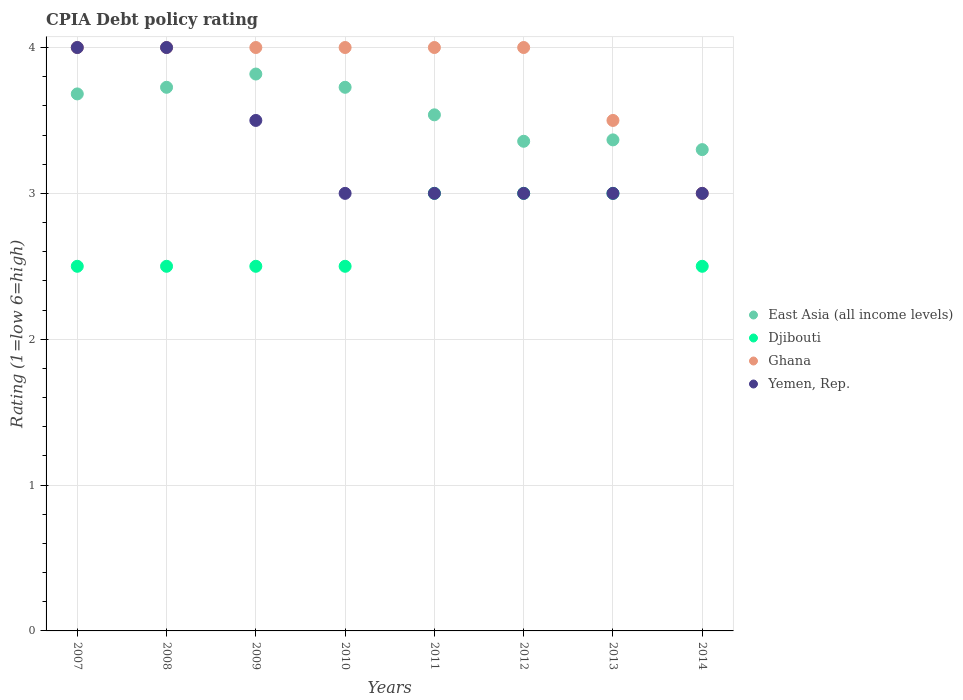How many different coloured dotlines are there?
Your response must be concise. 4. Across all years, what is the maximum CPIA rating in East Asia (all income levels)?
Offer a very short reply. 3.82. What is the total CPIA rating in Djibouti in the graph?
Provide a succinct answer. 21.5. What is the difference between the CPIA rating in Yemen, Rep. in 2013 and the CPIA rating in Djibouti in 2012?
Keep it short and to the point. 0. What is the average CPIA rating in Ghana per year?
Ensure brevity in your answer.  3.81. In the year 2010, what is the difference between the CPIA rating in East Asia (all income levels) and CPIA rating in Ghana?
Offer a very short reply. -0.27. In how many years, is the CPIA rating in East Asia (all income levels) greater than 3.4?
Offer a terse response. 5. What is the difference between the highest and the second highest CPIA rating in Yemen, Rep.?
Your answer should be compact. 0. Is the CPIA rating in Yemen, Rep. strictly greater than the CPIA rating in Djibouti over the years?
Offer a terse response. No. What is the difference between two consecutive major ticks on the Y-axis?
Offer a very short reply. 1. Does the graph contain any zero values?
Ensure brevity in your answer.  No. Where does the legend appear in the graph?
Your response must be concise. Center right. What is the title of the graph?
Provide a short and direct response. CPIA Debt policy rating. What is the label or title of the X-axis?
Your response must be concise. Years. What is the label or title of the Y-axis?
Your answer should be very brief. Rating (1=low 6=high). What is the Rating (1=low 6=high) of East Asia (all income levels) in 2007?
Your answer should be compact. 3.68. What is the Rating (1=low 6=high) of Yemen, Rep. in 2007?
Offer a very short reply. 4. What is the Rating (1=low 6=high) in East Asia (all income levels) in 2008?
Make the answer very short. 3.73. What is the Rating (1=low 6=high) of Ghana in 2008?
Make the answer very short. 4. What is the Rating (1=low 6=high) in East Asia (all income levels) in 2009?
Your answer should be compact. 3.82. What is the Rating (1=low 6=high) in East Asia (all income levels) in 2010?
Your response must be concise. 3.73. What is the Rating (1=low 6=high) in Djibouti in 2010?
Give a very brief answer. 2.5. What is the Rating (1=low 6=high) of East Asia (all income levels) in 2011?
Ensure brevity in your answer.  3.54. What is the Rating (1=low 6=high) in Djibouti in 2011?
Give a very brief answer. 3. What is the Rating (1=low 6=high) in Ghana in 2011?
Give a very brief answer. 4. What is the Rating (1=low 6=high) of Yemen, Rep. in 2011?
Provide a short and direct response. 3. What is the Rating (1=low 6=high) of East Asia (all income levels) in 2012?
Your answer should be compact. 3.36. What is the Rating (1=low 6=high) of Djibouti in 2012?
Your response must be concise. 3. What is the Rating (1=low 6=high) in Yemen, Rep. in 2012?
Your response must be concise. 3. What is the Rating (1=low 6=high) of East Asia (all income levels) in 2013?
Provide a short and direct response. 3.37. What is the Rating (1=low 6=high) in Yemen, Rep. in 2013?
Keep it short and to the point. 3. What is the Rating (1=low 6=high) of East Asia (all income levels) in 2014?
Give a very brief answer. 3.3. What is the Rating (1=low 6=high) in Djibouti in 2014?
Keep it short and to the point. 2.5. What is the Rating (1=low 6=high) in Ghana in 2014?
Provide a succinct answer. 3. What is the Rating (1=low 6=high) in Yemen, Rep. in 2014?
Make the answer very short. 3. Across all years, what is the maximum Rating (1=low 6=high) in East Asia (all income levels)?
Offer a very short reply. 3.82. Across all years, what is the maximum Rating (1=low 6=high) of Yemen, Rep.?
Keep it short and to the point. 4. Across all years, what is the minimum Rating (1=low 6=high) of Djibouti?
Your answer should be very brief. 2.5. What is the total Rating (1=low 6=high) in East Asia (all income levels) in the graph?
Provide a short and direct response. 28.52. What is the total Rating (1=low 6=high) of Ghana in the graph?
Your answer should be very brief. 30.5. What is the difference between the Rating (1=low 6=high) of East Asia (all income levels) in 2007 and that in 2008?
Keep it short and to the point. -0.05. What is the difference between the Rating (1=low 6=high) of Ghana in 2007 and that in 2008?
Give a very brief answer. 0. What is the difference between the Rating (1=low 6=high) of Yemen, Rep. in 2007 and that in 2008?
Your answer should be very brief. 0. What is the difference between the Rating (1=low 6=high) of East Asia (all income levels) in 2007 and that in 2009?
Ensure brevity in your answer.  -0.14. What is the difference between the Rating (1=low 6=high) in Djibouti in 2007 and that in 2009?
Ensure brevity in your answer.  0. What is the difference between the Rating (1=low 6=high) of Ghana in 2007 and that in 2009?
Ensure brevity in your answer.  0. What is the difference between the Rating (1=low 6=high) of East Asia (all income levels) in 2007 and that in 2010?
Provide a short and direct response. -0.05. What is the difference between the Rating (1=low 6=high) of Djibouti in 2007 and that in 2010?
Give a very brief answer. 0. What is the difference between the Rating (1=low 6=high) in Ghana in 2007 and that in 2010?
Your response must be concise. 0. What is the difference between the Rating (1=low 6=high) of East Asia (all income levels) in 2007 and that in 2011?
Ensure brevity in your answer.  0.14. What is the difference between the Rating (1=low 6=high) of Yemen, Rep. in 2007 and that in 2011?
Your answer should be very brief. 1. What is the difference between the Rating (1=low 6=high) in East Asia (all income levels) in 2007 and that in 2012?
Give a very brief answer. 0.32. What is the difference between the Rating (1=low 6=high) in Djibouti in 2007 and that in 2012?
Give a very brief answer. -0.5. What is the difference between the Rating (1=low 6=high) in East Asia (all income levels) in 2007 and that in 2013?
Keep it short and to the point. 0.32. What is the difference between the Rating (1=low 6=high) in Ghana in 2007 and that in 2013?
Offer a terse response. 0.5. What is the difference between the Rating (1=low 6=high) in East Asia (all income levels) in 2007 and that in 2014?
Offer a terse response. 0.38. What is the difference between the Rating (1=low 6=high) in Djibouti in 2007 and that in 2014?
Make the answer very short. 0. What is the difference between the Rating (1=low 6=high) of Ghana in 2007 and that in 2014?
Your answer should be compact. 1. What is the difference between the Rating (1=low 6=high) in Yemen, Rep. in 2007 and that in 2014?
Keep it short and to the point. 1. What is the difference between the Rating (1=low 6=high) of East Asia (all income levels) in 2008 and that in 2009?
Provide a short and direct response. -0.09. What is the difference between the Rating (1=low 6=high) of Djibouti in 2008 and that in 2010?
Your response must be concise. 0. What is the difference between the Rating (1=low 6=high) of Yemen, Rep. in 2008 and that in 2010?
Make the answer very short. 1. What is the difference between the Rating (1=low 6=high) in East Asia (all income levels) in 2008 and that in 2011?
Give a very brief answer. 0.19. What is the difference between the Rating (1=low 6=high) of Ghana in 2008 and that in 2011?
Keep it short and to the point. 0. What is the difference between the Rating (1=low 6=high) in East Asia (all income levels) in 2008 and that in 2012?
Offer a very short reply. 0.37. What is the difference between the Rating (1=low 6=high) of Djibouti in 2008 and that in 2012?
Provide a short and direct response. -0.5. What is the difference between the Rating (1=low 6=high) in Ghana in 2008 and that in 2012?
Your answer should be very brief. 0. What is the difference between the Rating (1=low 6=high) of East Asia (all income levels) in 2008 and that in 2013?
Keep it short and to the point. 0.36. What is the difference between the Rating (1=low 6=high) in Djibouti in 2008 and that in 2013?
Give a very brief answer. -0.5. What is the difference between the Rating (1=low 6=high) of Ghana in 2008 and that in 2013?
Your answer should be compact. 0.5. What is the difference between the Rating (1=low 6=high) in East Asia (all income levels) in 2008 and that in 2014?
Offer a very short reply. 0.43. What is the difference between the Rating (1=low 6=high) in Yemen, Rep. in 2008 and that in 2014?
Your response must be concise. 1. What is the difference between the Rating (1=low 6=high) in East Asia (all income levels) in 2009 and that in 2010?
Your answer should be compact. 0.09. What is the difference between the Rating (1=low 6=high) in Yemen, Rep. in 2009 and that in 2010?
Keep it short and to the point. 0.5. What is the difference between the Rating (1=low 6=high) in East Asia (all income levels) in 2009 and that in 2011?
Make the answer very short. 0.28. What is the difference between the Rating (1=low 6=high) in Djibouti in 2009 and that in 2011?
Ensure brevity in your answer.  -0.5. What is the difference between the Rating (1=low 6=high) of East Asia (all income levels) in 2009 and that in 2012?
Your response must be concise. 0.46. What is the difference between the Rating (1=low 6=high) of East Asia (all income levels) in 2009 and that in 2013?
Ensure brevity in your answer.  0.45. What is the difference between the Rating (1=low 6=high) of Djibouti in 2009 and that in 2013?
Offer a very short reply. -0.5. What is the difference between the Rating (1=low 6=high) in Ghana in 2009 and that in 2013?
Offer a terse response. 0.5. What is the difference between the Rating (1=low 6=high) of East Asia (all income levels) in 2009 and that in 2014?
Give a very brief answer. 0.52. What is the difference between the Rating (1=low 6=high) in Djibouti in 2009 and that in 2014?
Give a very brief answer. 0. What is the difference between the Rating (1=low 6=high) of East Asia (all income levels) in 2010 and that in 2011?
Offer a very short reply. 0.19. What is the difference between the Rating (1=low 6=high) of Ghana in 2010 and that in 2011?
Your response must be concise. 0. What is the difference between the Rating (1=low 6=high) in Yemen, Rep. in 2010 and that in 2011?
Your response must be concise. 0. What is the difference between the Rating (1=low 6=high) of East Asia (all income levels) in 2010 and that in 2012?
Offer a very short reply. 0.37. What is the difference between the Rating (1=low 6=high) in Ghana in 2010 and that in 2012?
Your answer should be compact. 0. What is the difference between the Rating (1=low 6=high) of East Asia (all income levels) in 2010 and that in 2013?
Provide a short and direct response. 0.36. What is the difference between the Rating (1=low 6=high) of Djibouti in 2010 and that in 2013?
Provide a succinct answer. -0.5. What is the difference between the Rating (1=low 6=high) of Yemen, Rep. in 2010 and that in 2013?
Your answer should be compact. 0. What is the difference between the Rating (1=low 6=high) of East Asia (all income levels) in 2010 and that in 2014?
Your answer should be compact. 0.43. What is the difference between the Rating (1=low 6=high) in Djibouti in 2010 and that in 2014?
Your response must be concise. 0. What is the difference between the Rating (1=low 6=high) in Yemen, Rep. in 2010 and that in 2014?
Offer a terse response. 0. What is the difference between the Rating (1=low 6=high) of East Asia (all income levels) in 2011 and that in 2012?
Give a very brief answer. 0.18. What is the difference between the Rating (1=low 6=high) of Ghana in 2011 and that in 2012?
Ensure brevity in your answer.  0. What is the difference between the Rating (1=low 6=high) of Yemen, Rep. in 2011 and that in 2012?
Make the answer very short. 0. What is the difference between the Rating (1=low 6=high) of East Asia (all income levels) in 2011 and that in 2013?
Ensure brevity in your answer.  0.17. What is the difference between the Rating (1=low 6=high) of Djibouti in 2011 and that in 2013?
Provide a succinct answer. 0. What is the difference between the Rating (1=low 6=high) of Ghana in 2011 and that in 2013?
Provide a short and direct response. 0.5. What is the difference between the Rating (1=low 6=high) of Yemen, Rep. in 2011 and that in 2013?
Keep it short and to the point. 0. What is the difference between the Rating (1=low 6=high) of East Asia (all income levels) in 2011 and that in 2014?
Ensure brevity in your answer.  0.24. What is the difference between the Rating (1=low 6=high) of Djibouti in 2011 and that in 2014?
Your answer should be very brief. 0.5. What is the difference between the Rating (1=low 6=high) in Ghana in 2011 and that in 2014?
Provide a short and direct response. 1. What is the difference between the Rating (1=low 6=high) in East Asia (all income levels) in 2012 and that in 2013?
Provide a succinct answer. -0.01. What is the difference between the Rating (1=low 6=high) in Ghana in 2012 and that in 2013?
Give a very brief answer. 0.5. What is the difference between the Rating (1=low 6=high) in East Asia (all income levels) in 2012 and that in 2014?
Keep it short and to the point. 0.06. What is the difference between the Rating (1=low 6=high) in Djibouti in 2012 and that in 2014?
Give a very brief answer. 0.5. What is the difference between the Rating (1=low 6=high) of Ghana in 2012 and that in 2014?
Provide a succinct answer. 1. What is the difference between the Rating (1=low 6=high) in Yemen, Rep. in 2012 and that in 2014?
Make the answer very short. 0. What is the difference between the Rating (1=low 6=high) of East Asia (all income levels) in 2013 and that in 2014?
Offer a very short reply. 0.07. What is the difference between the Rating (1=low 6=high) of Ghana in 2013 and that in 2014?
Keep it short and to the point. 0.5. What is the difference between the Rating (1=low 6=high) in East Asia (all income levels) in 2007 and the Rating (1=low 6=high) in Djibouti in 2008?
Give a very brief answer. 1.18. What is the difference between the Rating (1=low 6=high) of East Asia (all income levels) in 2007 and the Rating (1=low 6=high) of Ghana in 2008?
Make the answer very short. -0.32. What is the difference between the Rating (1=low 6=high) of East Asia (all income levels) in 2007 and the Rating (1=low 6=high) of Yemen, Rep. in 2008?
Provide a succinct answer. -0.32. What is the difference between the Rating (1=low 6=high) in East Asia (all income levels) in 2007 and the Rating (1=low 6=high) in Djibouti in 2009?
Provide a short and direct response. 1.18. What is the difference between the Rating (1=low 6=high) of East Asia (all income levels) in 2007 and the Rating (1=low 6=high) of Ghana in 2009?
Make the answer very short. -0.32. What is the difference between the Rating (1=low 6=high) of East Asia (all income levels) in 2007 and the Rating (1=low 6=high) of Yemen, Rep. in 2009?
Offer a terse response. 0.18. What is the difference between the Rating (1=low 6=high) in Djibouti in 2007 and the Rating (1=low 6=high) in Ghana in 2009?
Offer a terse response. -1.5. What is the difference between the Rating (1=low 6=high) in Ghana in 2007 and the Rating (1=low 6=high) in Yemen, Rep. in 2009?
Make the answer very short. 0.5. What is the difference between the Rating (1=low 6=high) of East Asia (all income levels) in 2007 and the Rating (1=low 6=high) of Djibouti in 2010?
Your response must be concise. 1.18. What is the difference between the Rating (1=low 6=high) in East Asia (all income levels) in 2007 and the Rating (1=low 6=high) in Ghana in 2010?
Provide a short and direct response. -0.32. What is the difference between the Rating (1=low 6=high) of East Asia (all income levels) in 2007 and the Rating (1=low 6=high) of Yemen, Rep. in 2010?
Your answer should be compact. 0.68. What is the difference between the Rating (1=low 6=high) of Djibouti in 2007 and the Rating (1=low 6=high) of Ghana in 2010?
Your answer should be compact. -1.5. What is the difference between the Rating (1=low 6=high) of Djibouti in 2007 and the Rating (1=low 6=high) of Yemen, Rep. in 2010?
Your answer should be very brief. -0.5. What is the difference between the Rating (1=low 6=high) of Ghana in 2007 and the Rating (1=low 6=high) of Yemen, Rep. in 2010?
Provide a short and direct response. 1. What is the difference between the Rating (1=low 6=high) in East Asia (all income levels) in 2007 and the Rating (1=low 6=high) in Djibouti in 2011?
Provide a succinct answer. 0.68. What is the difference between the Rating (1=low 6=high) of East Asia (all income levels) in 2007 and the Rating (1=low 6=high) of Ghana in 2011?
Your response must be concise. -0.32. What is the difference between the Rating (1=low 6=high) of East Asia (all income levels) in 2007 and the Rating (1=low 6=high) of Yemen, Rep. in 2011?
Offer a very short reply. 0.68. What is the difference between the Rating (1=low 6=high) of Djibouti in 2007 and the Rating (1=low 6=high) of Ghana in 2011?
Keep it short and to the point. -1.5. What is the difference between the Rating (1=low 6=high) of Djibouti in 2007 and the Rating (1=low 6=high) of Yemen, Rep. in 2011?
Provide a succinct answer. -0.5. What is the difference between the Rating (1=low 6=high) of East Asia (all income levels) in 2007 and the Rating (1=low 6=high) of Djibouti in 2012?
Make the answer very short. 0.68. What is the difference between the Rating (1=low 6=high) of East Asia (all income levels) in 2007 and the Rating (1=low 6=high) of Ghana in 2012?
Your answer should be compact. -0.32. What is the difference between the Rating (1=low 6=high) of East Asia (all income levels) in 2007 and the Rating (1=low 6=high) of Yemen, Rep. in 2012?
Make the answer very short. 0.68. What is the difference between the Rating (1=low 6=high) in East Asia (all income levels) in 2007 and the Rating (1=low 6=high) in Djibouti in 2013?
Your answer should be compact. 0.68. What is the difference between the Rating (1=low 6=high) in East Asia (all income levels) in 2007 and the Rating (1=low 6=high) in Ghana in 2013?
Provide a short and direct response. 0.18. What is the difference between the Rating (1=low 6=high) in East Asia (all income levels) in 2007 and the Rating (1=low 6=high) in Yemen, Rep. in 2013?
Keep it short and to the point. 0.68. What is the difference between the Rating (1=low 6=high) of Djibouti in 2007 and the Rating (1=low 6=high) of Ghana in 2013?
Provide a succinct answer. -1. What is the difference between the Rating (1=low 6=high) in East Asia (all income levels) in 2007 and the Rating (1=low 6=high) in Djibouti in 2014?
Offer a very short reply. 1.18. What is the difference between the Rating (1=low 6=high) in East Asia (all income levels) in 2007 and the Rating (1=low 6=high) in Ghana in 2014?
Offer a terse response. 0.68. What is the difference between the Rating (1=low 6=high) of East Asia (all income levels) in 2007 and the Rating (1=low 6=high) of Yemen, Rep. in 2014?
Provide a short and direct response. 0.68. What is the difference between the Rating (1=low 6=high) in Djibouti in 2007 and the Rating (1=low 6=high) in Ghana in 2014?
Your answer should be compact. -0.5. What is the difference between the Rating (1=low 6=high) in East Asia (all income levels) in 2008 and the Rating (1=low 6=high) in Djibouti in 2009?
Provide a short and direct response. 1.23. What is the difference between the Rating (1=low 6=high) in East Asia (all income levels) in 2008 and the Rating (1=low 6=high) in Ghana in 2009?
Give a very brief answer. -0.27. What is the difference between the Rating (1=low 6=high) in East Asia (all income levels) in 2008 and the Rating (1=low 6=high) in Yemen, Rep. in 2009?
Give a very brief answer. 0.23. What is the difference between the Rating (1=low 6=high) of Djibouti in 2008 and the Rating (1=low 6=high) of Ghana in 2009?
Provide a short and direct response. -1.5. What is the difference between the Rating (1=low 6=high) of East Asia (all income levels) in 2008 and the Rating (1=low 6=high) of Djibouti in 2010?
Provide a short and direct response. 1.23. What is the difference between the Rating (1=low 6=high) of East Asia (all income levels) in 2008 and the Rating (1=low 6=high) of Ghana in 2010?
Your answer should be compact. -0.27. What is the difference between the Rating (1=low 6=high) of East Asia (all income levels) in 2008 and the Rating (1=low 6=high) of Yemen, Rep. in 2010?
Keep it short and to the point. 0.73. What is the difference between the Rating (1=low 6=high) in Djibouti in 2008 and the Rating (1=low 6=high) in Yemen, Rep. in 2010?
Your response must be concise. -0.5. What is the difference between the Rating (1=low 6=high) of East Asia (all income levels) in 2008 and the Rating (1=low 6=high) of Djibouti in 2011?
Make the answer very short. 0.73. What is the difference between the Rating (1=low 6=high) of East Asia (all income levels) in 2008 and the Rating (1=low 6=high) of Ghana in 2011?
Offer a terse response. -0.27. What is the difference between the Rating (1=low 6=high) in East Asia (all income levels) in 2008 and the Rating (1=low 6=high) in Yemen, Rep. in 2011?
Your answer should be very brief. 0.73. What is the difference between the Rating (1=low 6=high) of Djibouti in 2008 and the Rating (1=low 6=high) of Yemen, Rep. in 2011?
Keep it short and to the point. -0.5. What is the difference between the Rating (1=low 6=high) of East Asia (all income levels) in 2008 and the Rating (1=low 6=high) of Djibouti in 2012?
Your answer should be very brief. 0.73. What is the difference between the Rating (1=low 6=high) of East Asia (all income levels) in 2008 and the Rating (1=low 6=high) of Ghana in 2012?
Your response must be concise. -0.27. What is the difference between the Rating (1=low 6=high) of East Asia (all income levels) in 2008 and the Rating (1=low 6=high) of Yemen, Rep. in 2012?
Ensure brevity in your answer.  0.73. What is the difference between the Rating (1=low 6=high) in Djibouti in 2008 and the Rating (1=low 6=high) in Yemen, Rep. in 2012?
Your answer should be compact. -0.5. What is the difference between the Rating (1=low 6=high) in Ghana in 2008 and the Rating (1=low 6=high) in Yemen, Rep. in 2012?
Provide a succinct answer. 1. What is the difference between the Rating (1=low 6=high) in East Asia (all income levels) in 2008 and the Rating (1=low 6=high) in Djibouti in 2013?
Give a very brief answer. 0.73. What is the difference between the Rating (1=low 6=high) of East Asia (all income levels) in 2008 and the Rating (1=low 6=high) of Ghana in 2013?
Provide a short and direct response. 0.23. What is the difference between the Rating (1=low 6=high) of East Asia (all income levels) in 2008 and the Rating (1=low 6=high) of Yemen, Rep. in 2013?
Ensure brevity in your answer.  0.73. What is the difference between the Rating (1=low 6=high) of Djibouti in 2008 and the Rating (1=low 6=high) of Ghana in 2013?
Provide a succinct answer. -1. What is the difference between the Rating (1=low 6=high) of Djibouti in 2008 and the Rating (1=low 6=high) of Yemen, Rep. in 2013?
Keep it short and to the point. -0.5. What is the difference between the Rating (1=low 6=high) of East Asia (all income levels) in 2008 and the Rating (1=low 6=high) of Djibouti in 2014?
Provide a succinct answer. 1.23. What is the difference between the Rating (1=low 6=high) of East Asia (all income levels) in 2008 and the Rating (1=low 6=high) of Ghana in 2014?
Keep it short and to the point. 0.73. What is the difference between the Rating (1=low 6=high) in East Asia (all income levels) in 2008 and the Rating (1=low 6=high) in Yemen, Rep. in 2014?
Offer a very short reply. 0.73. What is the difference between the Rating (1=low 6=high) in Djibouti in 2008 and the Rating (1=low 6=high) in Ghana in 2014?
Ensure brevity in your answer.  -0.5. What is the difference between the Rating (1=low 6=high) in Ghana in 2008 and the Rating (1=low 6=high) in Yemen, Rep. in 2014?
Keep it short and to the point. 1. What is the difference between the Rating (1=low 6=high) in East Asia (all income levels) in 2009 and the Rating (1=low 6=high) in Djibouti in 2010?
Offer a very short reply. 1.32. What is the difference between the Rating (1=low 6=high) of East Asia (all income levels) in 2009 and the Rating (1=low 6=high) of Ghana in 2010?
Make the answer very short. -0.18. What is the difference between the Rating (1=low 6=high) of East Asia (all income levels) in 2009 and the Rating (1=low 6=high) of Yemen, Rep. in 2010?
Your answer should be very brief. 0.82. What is the difference between the Rating (1=low 6=high) in Djibouti in 2009 and the Rating (1=low 6=high) in Yemen, Rep. in 2010?
Your answer should be compact. -0.5. What is the difference between the Rating (1=low 6=high) of Ghana in 2009 and the Rating (1=low 6=high) of Yemen, Rep. in 2010?
Provide a short and direct response. 1. What is the difference between the Rating (1=low 6=high) in East Asia (all income levels) in 2009 and the Rating (1=low 6=high) in Djibouti in 2011?
Provide a short and direct response. 0.82. What is the difference between the Rating (1=low 6=high) in East Asia (all income levels) in 2009 and the Rating (1=low 6=high) in Ghana in 2011?
Your answer should be very brief. -0.18. What is the difference between the Rating (1=low 6=high) of East Asia (all income levels) in 2009 and the Rating (1=low 6=high) of Yemen, Rep. in 2011?
Give a very brief answer. 0.82. What is the difference between the Rating (1=low 6=high) in Djibouti in 2009 and the Rating (1=low 6=high) in Yemen, Rep. in 2011?
Provide a short and direct response. -0.5. What is the difference between the Rating (1=low 6=high) of East Asia (all income levels) in 2009 and the Rating (1=low 6=high) of Djibouti in 2012?
Keep it short and to the point. 0.82. What is the difference between the Rating (1=low 6=high) in East Asia (all income levels) in 2009 and the Rating (1=low 6=high) in Ghana in 2012?
Your answer should be very brief. -0.18. What is the difference between the Rating (1=low 6=high) of East Asia (all income levels) in 2009 and the Rating (1=low 6=high) of Yemen, Rep. in 2012?
Provide a succinct answer. 0.82. What is the difference between the Rating (1=low 6=high) in Djibouti in 2009 and the Rating (1=low 6=high) in Yemen, Rep. in 2012?
Offer a terse response. -0.5. What is the difference between the Rating (1=low 6=high) of Ghana in 2009 and the Rating (1=low 6=high) of Yemen, Rep. in 2012?
Your answer should be very brief. 1. What is the difference between the Rating (1=low 6=high) of East Asia (all income levels) in 2009 and the Rating (1=low 6=high) of Djibouti in 2013?
Make the answer very short. 0.82. What is the difference between the Rating (1=low 6=high) of East Asia (all income levels) in 2009 and the Rating (1=low 6=high) of Ghana in 2013?
Your answer should be very brief. 0.32. What is the difference between the Rating (1=low 6=high) in East Asia (all income levels) in 2009 and the Rating (1=low 6=high) in Yemen, Rep. in 2013?
Your answer should be compact. 0.82. What is the difference between the Rating (1=low 6=high) in Djibouti in 2009 and the Rating (1=low 6=high) in Ghana in 2013?
Keep it short and to the point. -1. What is the difference between the Rating (1=low 6=high) of Djibouti in 2009 and the Rating (1=low 6=high) of Yemen, Rep. in 2013?
Your response must be concise. -0.5. What is the difference between the Rating (1=low 6=high) in East Asia (all income levels) in 2009 and the Rating (1=low 6=high) in Djibouti in 2014?
Give a very brief answer. 1.32. What is the difference between the Rating (1=low 6=high) in East Asia (all income levels) in 2009 and the Rating (1=low 6=high) in Ghana in 2014?
Give a very brief answer. 0.82. What is the difference between the Rating (1=low 6=high) in East Asia (all income levels) in 2009 and the Rating (1=low 6=high) in Yemen, Rep. in 2014?
Keep it short and to the point. 0.82. What is the difference between the Rating (1=low 6=high) of Djibouti in 2009 and the Rating (1=low 6=high) of Yemen, Rep. in 2014?
Make the answer very short. -0.5. What is the difference between the Rating (1=low 6=high) of East Asia (all income levels) in 2010 and the Rating (1=low 6=high) of Djibouti in 2011?
Offer a terse response. 0.73. What is the difference between the Rating (1=low 6=high) in East Asia (all income levels) in 2010 and the Rating (1=low 6=high) in Ghana in 2011?
Ensure brevity in your answer.  -0.27. What is the difference between the Rating (1=low 6=high) in East Asia (all income levels) in 2010 and the Rating (1=low 6=high) in Yemen, Rep. in 2011?
Provide a short and direct response. 0.73. What is the difference between the Rating (1=low 6=high) in Djibouti in 2010 and the Rating (1=low 6=high) in Ghana in 2011?
Provide a succinct answer. -1.5. What is the difference between the Rating (1=low 6=high) in Ghana in 2010 and the Rating (1=low 6=high) in Yemen, Rep. in 2011?
Make the answer very short. 1. What is the difference between the Rating (1=low 6=high) in East Asia (all income levels) in 2010 and the Rating (1=low 6=high) in Djibouti in 2012?
Provide a succinct answer. 0.73. What is the difference between the Rating (1=low 6=high) in East Asia (all income levels) in 2010 and the Rating (1=low 6=high) in Ghana in 2012?
Give a very brief answer. -0.27. What is the difference between the Rating (1=low 6=high) of East Asia (all income levels) in 2010 and the Rating (1=low 6=high) of Yemen, Rep. in 2012?
Provide a succinct answer. 0.73. What is the difference between the Rating (1=low 6=high) in Djibouti in 2010 and the Rating (1=low 6=high) in Yemen, Rep. in 2012?
Provide a succinct answer. -0.5. What is the difference between the Rating (1=low 6=high) in Ghana in 2010 and the Rating (1=low 6=high) in Yemen, Rep. in 2012?
Give a very brief answer. 1. What is the difference between the Rating (1=low 6=high) of East Asia (all income levels) in 2010 and the Rating (1=low 6=high) of Djibouti in 2013?
Your answer should be compact. 0.73. What is the difference between the Rating (1=low 6=high) in East Asia (all income levels) in 2010 and the Rating (1=low 6=high) in Ghana in 2013?
Your response must be concise. 0.23. What is the difference between the Rating (1=low 6=high) in East Asia (all income levels) in 2010 and the Rating (1=low 6=high) in Yemen, Rep. in 2013?
Your response must be concise. 0.73. What is the difference between the Rating (1=low 6=high) in Djibouti in 2010 and the Rating (1=low 6=high) in Ghana in 2013?
Provide a succinct answer. -1. What is the difference between the Rating (1=low 6=high) of Djibouti in 2010 and the Rating (1=low 6=high) of Yemen, Rep. in 2013?
Ensure brevity in your answer.  -0.5. What is the difference between the Rating (1=low 6=high) of Ghana in 2010 and the Rating (1=low 6=high) of Yemen, Rep. in 2013?
Make the answer very short. 1. What is the difference between the Rating (1=low 6=high) in East Asia (all income levels) in 2010 and the Rating (1=low 6=high) in Djibouti in 2014?
Offer a very short reply. 1.23. What is the difference between the Rating (1=low 6=high) in East Asia (all income levels) in 2010 and the Rating (1=low 6=high) in Ghana in 2014?
Your response must be concise. 0.73. What is the difference between the Rating (1=low 6=high) in East Asia (all income levels) in 2010 and the Rating (1=low 6=high) in Yemen, Rep. in 2014?
Your response must be concise. 0.73. What is the difference between the Rating (1=low 6=high) of Ghana in 2010 and the Rating (1=low 6=high) of Yemen, Rep. in 2014?
Your answer should be very brief. 1. What is the difference between the Rating (1=low 6=high) of East Asia (all income levels) in 2011 and the Rating (1=low 6=high) of Djibouti in 2012?
Your answer should be compact. 0.54. What is the difference between the Rating (1=low 6=high) in East Asia (all income levels) in 2011 and the Rating (1=low 6=high) in Ghana in 2012?
Keep it short and to the point. -0.46. What is the difference between the Rating (1=low 6=high) in East Asia (all income levels) in 2011 and the Rating (1=low 6=high) in Yemen, Rep. in 2012?
Your response must be concise. 0.54. What is the difference between the Rating (1=low 6=high) in Djibouti in 2011 and the Rating (1=low 6=high) in Yemen, Rep. in 2012?
Provide a succinct answer. 0. What is the difference between the Rating (1=low 6=high) in East Asia (all income levels) in 2011 and the Rating (1=low 6=high) in Djibouti in 2013?
Your response must be concise. 0.54. What is the difference between the Rating (1=low 6=high) in East Asia (all income levels) in 2011 and the Rating (1=low 6=high) in Ghana in 2013?
Provide a succinct answer. 0.04. What is the difference between the Rating (1=low 6=high) in East Asia (all income levels) in 2011 and the Rating (1=low 6=high) in Yemen, Rep. in 2013?
Your answer should be compact. 0.54. What is the difference between the Rating (1=low 6=high) in Djibouti in 2011 and the Rating (1=low 6=high) in Yemen, Rep. in 2013?
Keep it short and to the point. 0. What is the difference between the Rating (1=low 6=high) in East Asia (all income levels) in 2011 and the Rating (1=low 6=high) in Djibouti in 2014?
Make the answer very short. 1.04. What is the difference between the Rating (1=low 6=high) in East Asia (all income levels) in 2011 and the Rating (1=low 6=high) in Ghana in 2014?
Your response must be concise. 0.54. What is the difference between the Rating (1=low 6=high) of East Asia (all income levels) in 2011 and the Rating (1=low 6=high) of Yemen, Rep. in 2014?
Your response must be concise. 0.54. What is the difference between the Rating (1=low 6=high) in Ghana in 2011 and the Rating (1=low 6=high) in Yemen, Rep. in 2014?
Make the answer very short. 1. What is the difference between the Rating (1=low 6=high) in East Asia (all income levels) in 2012 and the Rating (1=low 6=high) in Djibouti in 2013?
Provide a short and direct response. 0.36. What is the difference between the Rating (1=low 6=high) in East Asia (all income levels) in 2012 and the Rating (1=low 6=high) in Ghana in 2013?
Your answer should be compact. -0.14. What is the difference between the Rating (1=low 6=high) in East Asia (all income levels) in 2012 and the Rating (1=low 6=high) in Yemen, Rep. in 2013?
Ensure brevity in your answer.  0.36. What is the difference between the Rating (1=low 6=high) of Ghana in 2012 and the Rating (1=low 6=high) of Yemen, Rep. in 2013?
Offer a terse response. 1. What is the difference between the Rating (1=low 6=high) in East Asia (all income levels) in 2012 and the Rating (1=low 6=high) in Djibouti in 2014?
Your answer should be compact. 0.86. What is the difference between the Rating (1=low 6=high) of East Asia (all income levels) in 2012 and the Rating (1=low 6=high) of Ghana in 2014?
Offer a very short reply. 0.36. What is the difference between the Rating (1=low 6=high) in East Asia (all income levels) in 2012 and the Rating (1=low 6=high) in Yemen, Rep. in 2014?
Give a very brief answer. 0.36. What is the difference between the Rating (1=low 6=high) in East Asia (all income levels) in 2013 and the Rating (1=low 6=high) in Djibouti in 2014?
Offer a very short reply. 0.87. What is the difference between the Rating (1=low 6=high) in East Asia (all income levels) in 2013 and the Rating (1=low 6=high) in Ghana in 2014?
Offer a very short reply. 0.37. What is the difference between the Rating (1=low 6=high) in East Asia (all income levels) in 2013 and the Rating (1=low 6=high) in Yemen, Rep. in 2014?
Give a very brief answer. 0.37. What is the difference between the Rating (1=low 6=high) of Djibouti in 2013 and the Rating (1=low 6=high) of Yemen, Rep. in 2014?
Your answer should be compact. 0. What is the difference between the Rating (1=low 6=high) of Ghana in 2013 and the Rating (1=low 6=high) of Yemen, Rep. in 2014?
Your response must be concise. 0.5. What is the average Rating (1=low 6=high) of East Asia (all income levels) per year?
Provide a short and direct response. 3.56. What is the average Rating (1=low 6=high) of Djibouti per year?
Make the answer very short. 2.69. What is the average Rating (1=low 6=high) in Ghana per year?
Provide a short and direct response. 3.81. What is the average Rating (1=low 6=high) of Yemen, Rep. per year?
Offer a very short reply. 3.31. In the year 2007, what is the difference between the Rating (1=low 6=high) in East Asia (all income levels) and Rating (1=low 6=high) in Djibouti?
Provide a short and direct response. 1.18. In the year 2007, what is the difference between the Rating (1=low 6=high) in East Asia (all income levels) and Rating (1=low 6=high) in Ghana?
Your answer should be compact. -0.32. In the year 2007, what is the difference between the Rating (1=low 6=high) of East Asia (all income levels) and Rating (1=low 6=high) of Yemen, Rep.?
Give a very brief answer. -0.32. In the year 2007, what is the difference between the Rating (1=low 6=high) of Djibouti and Rating (1=low 6=high) of Ghana?
Offer a very short reply. -1.5. In the year 2007, what is the difference between the Rating (1=low 6=high) in Djibouti and Rating (1=low 6=high) in Yemen, Rep.?
Keep it short and to the point. -1.5. In the year 2008, what is the difference between the Rating (1=low 6=high) of East Asia (all income levels) and Rating (1=low 6=high) of Djibouti?
Your answer should be very brief. 1.23. In the year 2008, what is the difference between the Rating (1=low 6=high) of East Asia (all income levels) and Rating (1=low 6=high) of Ghana?
Ensure brevity in your answer.  -0.27. In the year 2008, what is the difference between the Rating (1=low 6=high) of East Asia (all income levels) and Rating (1=low 6=high) of Yemen, Rep.?
Offer a very short reply. -0.27. In the year 2008, what is the difference between the Rating (1=low 6=high) in Djibouti and Rating (1=low 6=high) in Ghana?
Give a very brief answer. -1.5. In the year 2008, what is the difference between the Rating (1=low 6=high) of Djibouti and Rating (1=low 6=high) of Yemen, Rep.?
Your response must be concise. -1.5. In the year 2008, what is the difference between the Rating (1=low 6=high) of Ghana and Rating (1=low 6=high) of Yemen, Rep.?
Offer a terse response. 0. In the year 2009, what is the difference between the Rating (1=low 6=high) in East Asia (all income levels) and Rating (1=low 6=high) in Djibouti?
Offer a terse response. 1.32. In the year 2009, what is the difference between the Rating (1=low 6=high) in East Asia (all income levels) and Rating (1=low 6=high) in Ghana?
Your answer should be compact. -0.18. In the year 2009, what is the difference between the Rating (1=low 6=high) in East Asia (all income levels) and Rating (1=low 6=high) in Yemen, Rep.?
Keep it short and to the point. 0.32. In the year 2009, what is the difference between the Rating (1=low 6=high) of Djibouti and Rating (1=low 6=high) of Ghana?
Provide a succinct answer. -1.5. In the year 2009, what is the difference between the Rating (1=low 6=high) of Ghana and Rating (1=low 6=high) of Yemen, Rep.?
Offer a very short reply. 0.5. In the year 2010, what is the difference between the Rating (1=low 6=high) of East Asia (all income levels) and Rating (1=low 6=high) of Djibouti?
Offer a very short reply. 1.23. In the year 2010, what is the difference between the Rating (1=low 6=high) in East Asia (all income levels) and Rating (1=low 6=high) in Ghana?
Provide a succinct answer. -0.27. In the year 2010, what is the difference between the Rating (1=low 6=high) of East Asia (all income levels) and Rating (1=low 6=high) of Yemen, Rep.?
Ensure brevity in your answer.  0.73. In the year 2010, what is the difference between the Rating (1=low 6=high) in Djibouti and Rating (1=low 6=high) in Ghana?
Keep it short and to the point. -1.5. In the year 2011, what is the difference between the Rating (1=low 6=high) in East Asia (all income levels) and Rating (1=low 6=high) in Djibouti?
Provide a succinct answer. 0.54. In the year 2011, what is the difference between the Rating (1=low 6=high) of East Asia (all income levels) and Rating (1=low 6=high) of Ghana?
Provide a short and direct response. -0.46. In the year 2011, what is the difference between the Rating (1=low 6=high) in East Asia (all income levels) and Rating (1=low 6=high) in Yemen, Rep.?
Make the answer very short. 0.54. In the year 2012, what is the difference between the Rating (1=low 6=high) in East Asia (all income levels) and Rating (1=low 6=high) in Djibouti?
Your response must be concise. 0.36. In the year 2012, what is the difference between the Rating (1=low 6=high) in East Asia (all income levels) and Rating (1=low 6=high) in Ghana?
Your response must be concise. -0.64. In the year 2012, what is the difference between the Rating (1=low 6=high) in East Asia (all income levels) and Rating (1=low 6=high) in Yemen, Rep.?
Your response must be concise. 0.36. In the year 2013, what is the difference between the Rating (1=low 6=high) in East Asia (all income levels) and Rating (1=low 6=high) in Djibouti?
Your answer should be very brief. 0.37. In the year 2013, what is the difference between the Rating (1=low 6=high) of East Asia (all income levels) and Rating (1=low 6=high) of Ghana?
Offer a terse response. -0.13. In the year 2013, what is the difference between the Rating (1=low 6=high) of East Asia (all income levels) and Rating (1=low 6=high) of Yemen, Rep.?
Give a very brief answer. 0.37. In the year 2013, what is the difference between the Rating (1=low 6=high) of Ghana and Rating (1=low 6=high) of Yemen, Rep.?
Make the answer very short. 0.5. In the year 2014, what is the difference between the Rating (1=low 6=high) of East Asia (all income levels) and Rating (1=low 6=high) of Djibouti?
Your answer should be very brief. 0.8. In the year 2014, what is the difference between the Rating (1=low 6=high) of Djibouti and Rating (1=low 6=high) of Ghana?
Make the answer very short. -0.5. In the year 2014, what is the difference between the Rating (1=low 6=high) in Djibouti and Rating (1=low 6=high) in Yemen, Rep.?
Provide a short and direct response. -0.5. What is the ratio of the Rating (1=low 6=high) of Ghana in 2007 to that in 2008?
Your answer should be compact. 1. What is the ratio of the Rating (1=low 6=high) in Yemen, Rep. in 2007 to that in 2008?
Offer a very short reply. 1. What is the ratio of the Rating (1=low 6=high) of East Asia (all income levels) in 2007 to that in 2009?
Your answer should be very brief. 0.96. What is the ratio of the Rating (1=low 6=high) of Ghana in 2007 to that in 2009?
Keep it short and to the point. 1. What is the ratio of the Rating (1=low 6=high) of Yemen, Rep. in 2007 to that in 2009?
Ensure brevity in your answer.  1.14. What is the ratio of the Rating (1=low 6=high) of Djibouti in 2007 to that in 2010?
Offer a terse response. 1. What is the ratio of the Rating (1=low 6=high) of East Asia (all income levels) in 2007 to that in 2011?
Offer a very short reply. 1.04. What is the ratio of the Rating (1=low 6=high) of Djibouti in 2007 to that in 2011?
Provide a short and direct response. 0.83. What is the ratio of the Rating (1=low 6=high) in Ghana in 2007 to that in 2011?
Provide a short and direct response. 1. What is the ratio of the Rating (1=low 6=high) of East Asia (all income levels) in 2007 to that in 2012?
Provide a succinct answer. 1.1. What is the ratio of the Rating (1=low 6=high) in Djibouti in 2007 to that in 2012?
Offer a terse response. 0.83. What is the ratio of the Rating (1=low 6=high) in Yemen, Rep. in 2007 to that in 2012?
Your response must be concise. 1.33. What is the ratio of the Rating (1=low 6=high) of East Asia (all income levels) in 2007 to that in 2013?
Give a very brief answer. 1.09. What is the ratio of the Rating (1=low 6=high) of Djibouti in 2007 to that in 2013?
Your response must be concise. 0.83. What is the ratio of the Rating (1=low 6=high) of Ghana in 2007 to that in 2013?
Provide a short and direct response. 1.14. What is the ratio of the Rating (1=low 6=high) in East Asia (all income levels) in 2007 to that in 2014?
Your answer should be compact. 1.12. What is the ratio of the Rating (1=low 6=high) of East Asia (all income levels) in 2008 to that in 2009?
Provide a short and direct response. 0.98. What is the ratio of the Rating (1=low 6=high) in Yemen, Rep. in 2008 to that in 2009?
Your response must be concise. 1.14. What is the ratio of the Rating (1=low 6=high) in East Asia (all income levels) in 2008 to that in 2010?
Make the answer very short. 1. What is the ratio of the Rating (1=low 6=high) in Djibouti in 2008 to that in 2010?
Make the answer very short. 1. What is the ratio of the Rating (1=low 6=high) in East Asia (all income levels) in 2008 to that in 2011?
Give a very brief answer. 1.05. What is the ratio of the Rating (1=low 6=high) in Djibouti in 2008 to that in 2011?
Offer a terse response. 0.83. What is the ratio of the Rating (1=low 6=high) in Ghana in 2008 to that in 2011?
Give a very brief answer. 1. What is the ratio of the Rating (1=low 6=high) in Yemen, Rep. in 2008 to that in 2011?
Give a very brief answer. 1.33. What is the ratio of the Rating (1=low 6=high) of East Asia (all income levels) in 2008 to that in 2012?
Provide a short and direct response. 1.11. What is the ratio of the Rating (1=low 6=high) of East Asia (all income levels) in 2008 to that in 2013?
Give a very brief answer. 1.11. What is the ratio of the Rating (1=low 6=high) of East Asia (all income levels) in 2008 to that in 2014?
Your answer should be very brief. 1.13. What is the ratio of the Rating (1=low 6=high) in Djibouti in 2008 to that in 2014?
Ensure brevity in your answer.  1. What is the ratio of the Rating (1=low 6=high) in Ghana in 2008 to that in 2014?
Provide a succinct answer. 1.33. What is the ratio of the Rating (1=low 6=high) in East Asia (all income levels) in 2009 to that in 2010?
Give a very brief answer. 1.02. What is the ratio of the Rating (1=low 6=high) in Djibouti in 2009 to that in 2010?
Your response must be concise. 1. What is the ratio of the Rating (1=low 6=high) in Ghana in 2009 to that in 2010?
Provide a short and direct response. 1. What is the ratio of the Rating (1=low 6=high) in Yemen, Rep. in 2009 to that in 2010?
Offer a terse response. 1.17. What is the ratio of the Rating (1=low 6=high) of East Asia (all income levels) in 2009 to that in 2011?
Provide a succinct answer. 1.08. What is the ratio of the Rating (1=low 6=high) of Djibouti in 2009 to that in 2011?
Make the answer very short. 0.83. What is the ratio of the Rating (1=low 6=high) of Ghana in 2009 to that in 2011?
Give a very brief answer. 1. What is the ratio of the Rating (1=low 6=high) of Yemen, Rep. in 2009 to that in 2011?
Your response must be concise. 1.17. What is the ratio of the Rating (1=low 6=high) in East Asia (all income levels) in 2009 to that in 2012?
Your response must be concise. 1.14. What is the ratio of the Rating (1=low 6=high) in East Asia (all income levels) in 2009 to that in 2013?
Provide a succinct answer. 1.13. What is the ratio of the Rating (1=low 6=high) of Djibouti in 2009 to that in 2013?
Make the answer very short. 0.83. What is the ratio of the Rating (1=low 6=high) in Yemen, Rep. in 2009 to that in 2013?
Your response must be concise. 1.17. What is the ratio of the Rating (1=low 6=high) of East Asia (all income levels) in 2009 to that in 2014?
Offer a terse response. 1.16. What is the ratio of the Rating (1=low 6=high) of Ghana in 2009 to that in 2014?
Your answer should be very brief. 1.33. What is the ratio of the Rating (1=low 6=high) in East Asia (all income levels) in 2010 to that in 2011?
Offer a very short reply. 1.05. What is the ratio of the Rating (1=low 6=high) in Djibouti in 2010 to that in 2011?
Your answer should be compact. 0.83. What is the ratio of the Rating (1=low 6=high) in Ghana in 2010 to that in 2011?
Your answer should be very brief. 1. What is the ratio of the Rating (1=low 6=high) in Yemen, Rep. in 2010 to that in 2011?
Your answer should be compact. 1. What is the ratio of the Rating (1=low 6=high) in East Asia (all income levels) in 2010 to that in 2012?
Give a very brief answer. 1.11. What is the ratio of the Rating (1=low 6=high) of Djibouti in 2010 to that in 2012?
Your response must be concise. 0.83. What is the ratio of the Rating (1=low 6=high) of East Asia (all income levels) in 2010 to that in 2013?
Your answer should be very brief. 1.11. What is the ratio of the Rating (1=low 6=high) of Ghana in 2010 to that in 2013?
Your answer should be compact. 1.14. What is the ratio of the Rating (1=low 6=high) of Yemen, Rep. in 2010 to that in 2013?
Provide a succinct answer. 1. What is the ratio of the Rating (1=low 6=high) in East Asia (all income levels) in 2010 to that in 2014?
Make the answer very short. 1.13. What is the ratio of the Rating (1=low 6=high) of Djibouti in 2010 to that in 2014?
Your answer should be very brief. 1. What is the ratio of the Rating (1=low 6=high) in Ghana in 2010 to that in 2014?
Keep it short and to the point. 1.33. What is the ratio of the Rating (1=low 6=high) in East Asia (all income levels) in 2011 to that in 2012?
Your answer should be compact. 1.05. What is the ratio of the Rating (1=low 6=high) of Ghana in 2011 to that in 2012?
Offer a very short reply. 1. What is the ratio of the Rating (1=low 6=high) in East Asia (all income levels) in 2011 to that in 2013?
Offer a very short reply. 1.05. What is the ratio of the Rating (1=low 6=high) in Ghana in 2011 to that in 2013?
Provide a short and direct response. 1.14. What is the ratio of the Rating (1=low 6=high) in Yemen, Rep. in 2011 to that in 2013?
Provide a succinct answer. 1. What is the ratio of the Rating (1=low 6=high) in East Asia (all income levels) in 2011 to that in 2014?
Ensure brevity in your answer.  1.07. What is the ratio of the Rating (1=low 6=high) of Djibouti in 2011 to that in 2014?
Make the answer very short. 1.2. What is the ratio of the Rating (1=low 6=high) in Ghana in 2011 to that in 2014?
Ensure brevity in your answer.  1.33. What is the ratio of the Rating (1=low 6=high) of Yemen, Rep. in 2011 to that in 2014?
Your response must be concise. 1. What is the ratio of the Rating (1=low 6=high) in East Asia (all income levels) in 2012 to that in 2013?
Your answer should be compact. 1. What is the ratio of the Rating (1=low 6=high) of Djibouti in 2012 to that in 2013?
Your answer should be very brief. 1. What is the ratio of the Rating (1=low 6=high) of Ghana in 2012 to that in 2013?
Your answer should be compact. 1.14. What is the ratio of the Rating (1=low 6=high) of Yemen, Rep. in 2012 to that in 2013?
Your answer should be very brief. 1. What is the ratio of the Rating (1=low 6=high) in East Asia (all income levels) in 2012 to that in 2014?
Ensure brevity in your answer.  1.02. What is the ratio of the Rating (1=low 6=high) in Ghana in 2012 to that in 2014?
Keep it short and to the point. 1.33. What is the ratio of the Rating (1=low 6=high) in Yemen, Rep. in 2012 to that in 2014?
Your response must be concise. 1. What is the ratio of the Rating (1=low 6=high) in East Asia (all income levels) in 2013 to that in 2014?
Your answer should be compact. 1.02. What is the ratio of the Rating (1=low 6=high) of Djibouti in 2013 to that in 2014?
Offer a very short reply. 1.2. What is the difference between the highest and the second highest Rating (1=low 6=high) of East Asia (all income levels)?
Provide a succinct answer. 0.09. What is the difference between the highest and the second highest Rating (1=low 6=high) of Djibouti?
Provide a succinct answer. 0. What is the difference between the highest and the second highest Rating (1=low 6=high) of Yemen, Rep.?
Offer a very short reply. 0. What is the difference between the highest and the lowest Rating (1=low 6=high) of East Asia (all income levels)?
Offer a terse response. 0.52. What is the difference between the highest and the lowest Rating (1=low 6=high) in Yemen, Rep.?
Give a very brief answer. 1. 